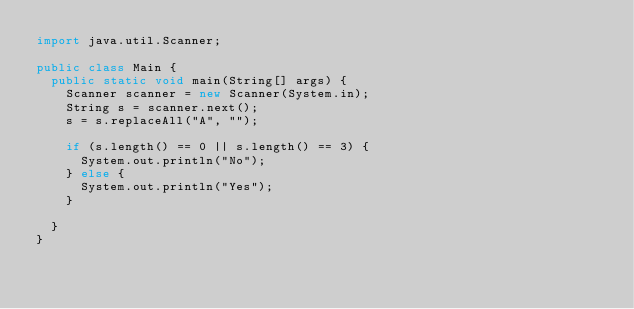Convert code to text. <code><loc_0><loc_0><loc_500><loc_500><_Java_>import java.util.Scanner;

public class Main {
	public static void main(String[] args) {
		Scanner scanner = new Scanner(System.in);
		String s = scanner.next();
		s = s.replaceAll("A", "");
		
		if (s.length() == 0 || s.length() == 3) {
			System.out.println("No");
		} else {
			System.out.println("Yes");
		}
		
	}
}	</code> 